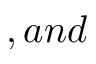<formula> <loc_0><loc_0><loc_500><loc_500>, a n d</formula> 